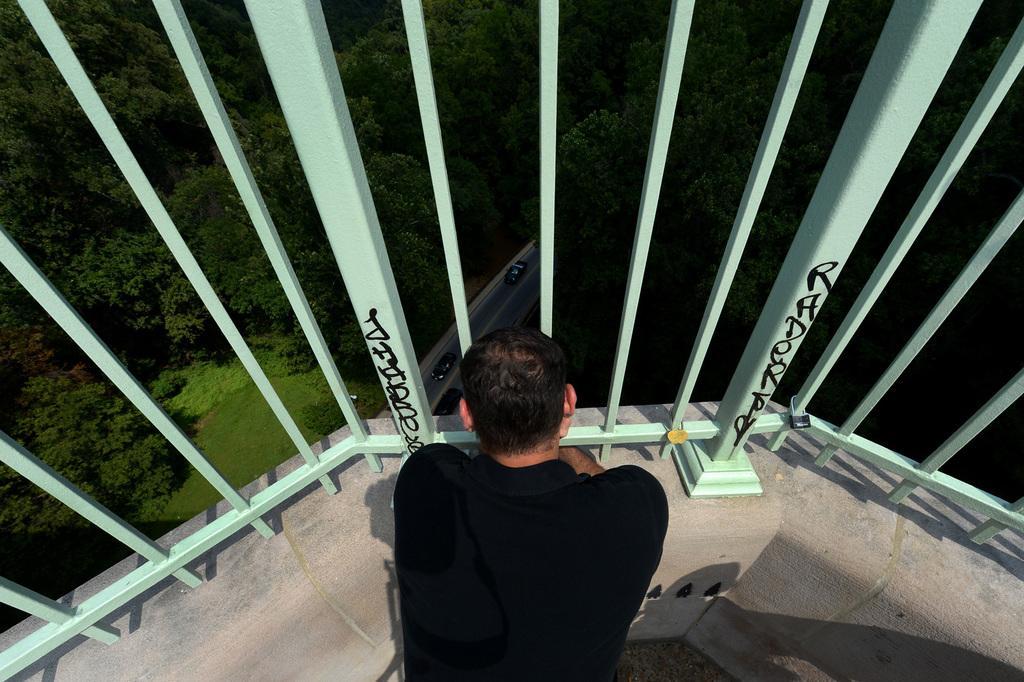Could you give a brief overview of what you see in this image? In this image we can see a person sitting on the floor in front of the grills. In the background there are trees, motor vehicles on the road and ground. 